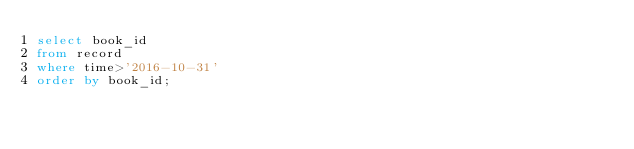<code> <loc_0><loc_0><loc_500><loc_500><_SQL_>select book_id
from record
where time>'2016-10-31'
order by book_id;</code> 